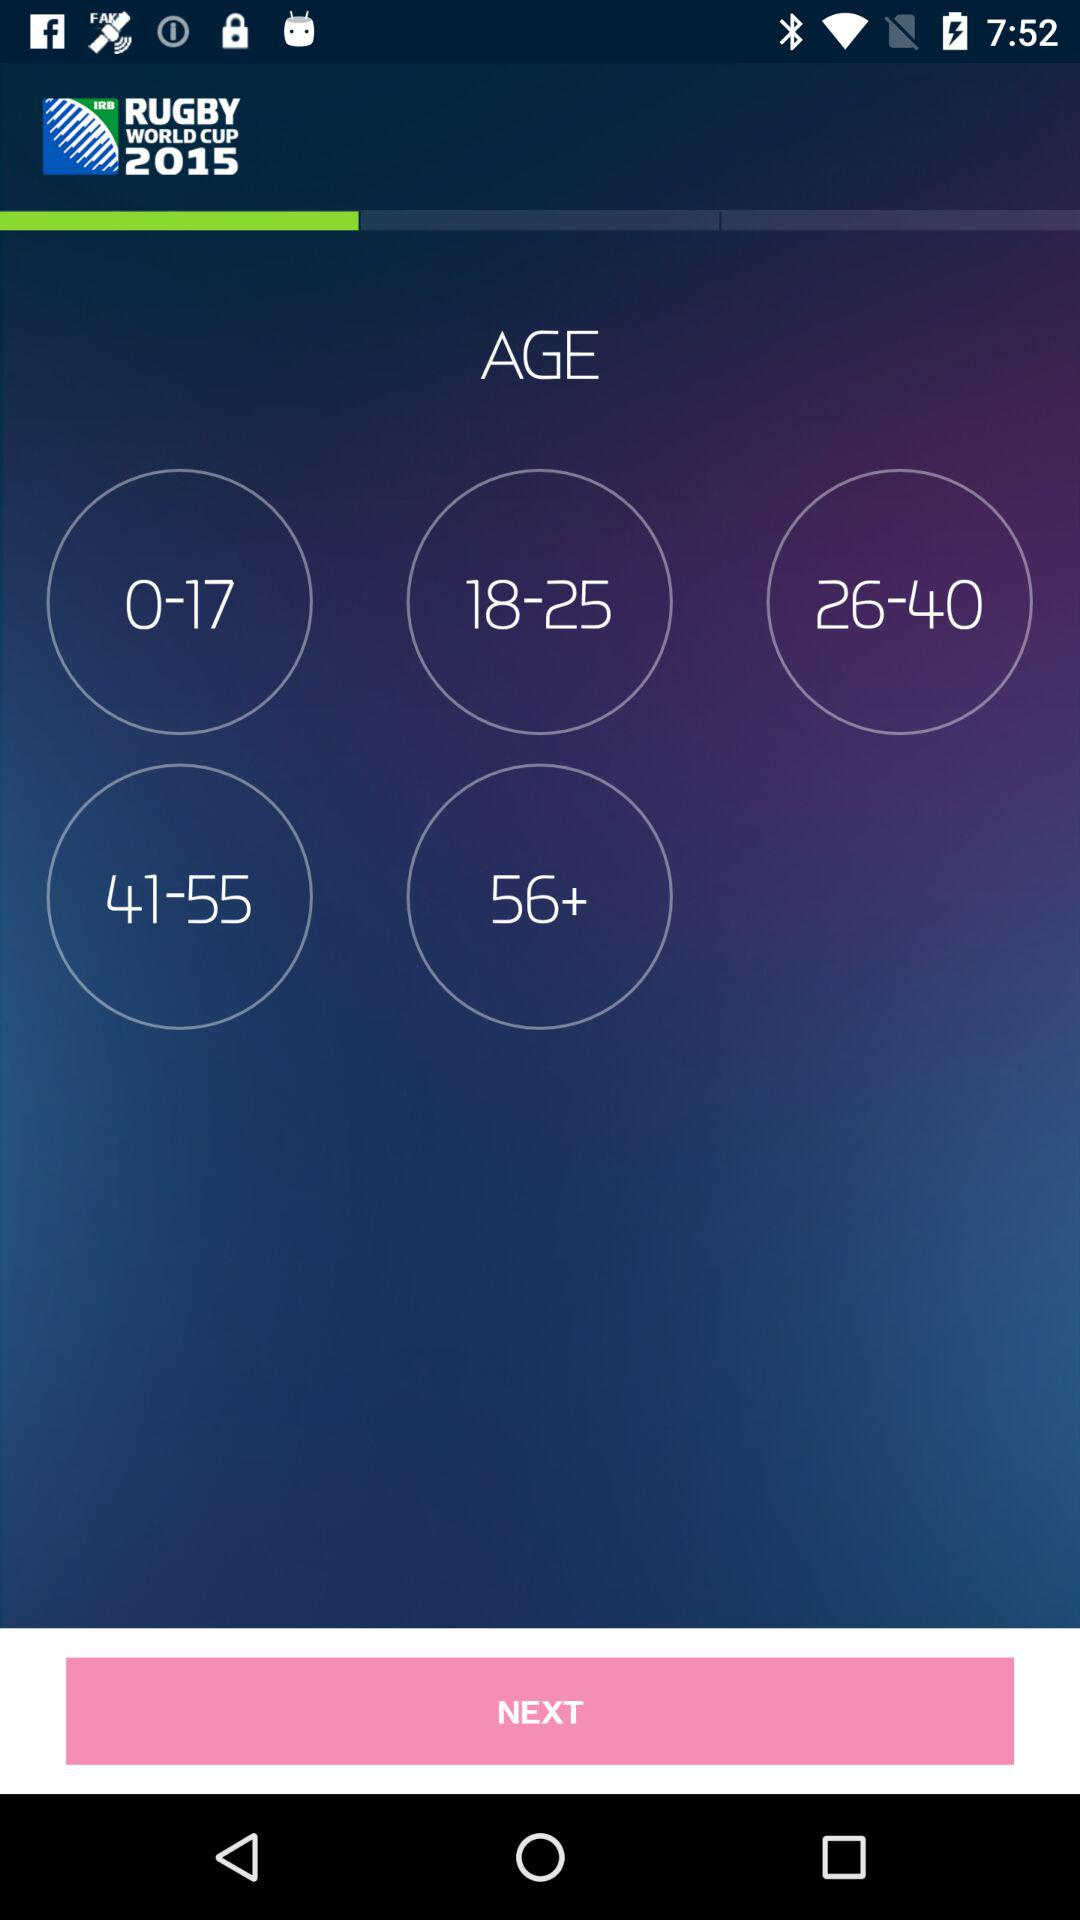How many age ranges are there?
Answer the question using a single word or phrase. 5 